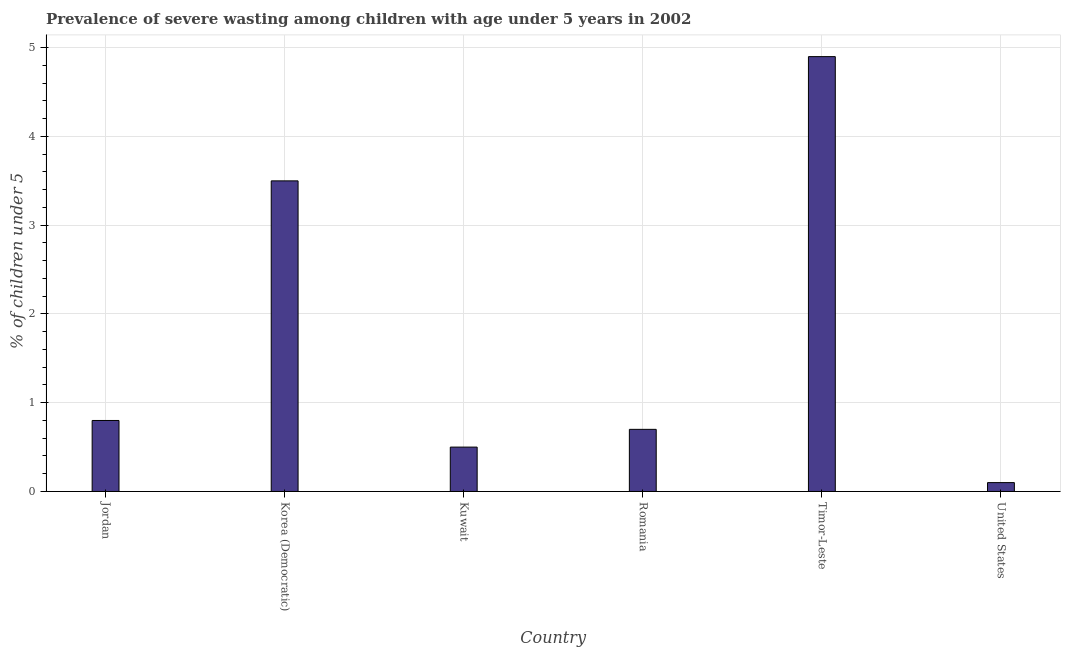What is the title of the graph?
Keep it short and to the point. Prevalence of severe wasting among children with age under 5 years in 2002. What is the label or title of the Y-axis?
Make the answer very short.  % of children under 5. What is the prevalence of severe wasting in United States?
Make the answer very short. 0.1. Across all countries, what is the maximum prevalence of severe wasting?
Offer a terse response. 4.9. Across all countries, what is the minimum prevalence of severe wasting?
Give a very brief answer. 0.1. In which country was the prevalence of severe wasting maximum?
Your response must be concise. Timor-Leste. In which country was the prevalence of severe wasting minimum?
Provide a succinct answer. United States. What is the sum of the prevalence of severe wasting?
Your response must be concise. 10.5. What is the difference between the prevalence of severe wasting in Romania and Timor-Leste?
Give a very brief answer. -4.2. What is the median prevalence of severe wasting?
Ensure brevity in your answer.  0.75. In how many countries, is the prevalence of severe wasting greater than 0.2 %?
Give a very brief answer. 5. What is the ratio of the prevalence of severe wasting in Jordan to that in Korea (Democratic)?
Ensure brevity in your answer.  0.23. Is the difference between the prevalence of severe wasting in Jordan and Korea (Democratic) greater than the difference between any two countries?
Keep it short and to the point. No. Is the sum of the prevalence of severe wasting in Korea (Democratic) and Romania greater than the maximum prevalence of severe wasting across all countries?
Give a very brief answer. No. In how many countries, is the prevalence of severe wasting greater than the average prevalence of severe wasting taken over all countries?
Offer a very short reply. 2. How many countries are there in the graph?
Offer a terse response. 6. What is the difference between two consecutive major ticks on the Y-axis?
Make the answer very short. 1. What is the  % of children under 5 in Jordan?
Offer a very short reply. 0.8. What is the  % of children under 5 of Korea (Democratic)?
Your response must be concise. 3.5. What is the  % of children under 5 in Romania?
Ensure brevity in your answer.  0.7. What is the  % of children under 5 of Timor-Leste?
Your answer should be compact. 4.9. What is the  % of children under 5 of United States?
Offer a very short reply. 0.1. What is the difference between the  % of children under 5 in Jordan and Romania?
Your answer should be compact. 0.1. What is the difference between the  % of children under 5 in Jordan and Timor-Leste?
Ensure brevity in your answer.  -4.1. What is the difference between the  % of children under 5 in Korea (Democratic) and Kuwait?
Your response must be concise. 3. What is the difference between the  % of children under 5 in Korea (Democratic) and Romania?
Your response must be concise. 2.8. What is the difference between the  % of children under 5 in Korea (Democratic) and United States?
Provide a short and direct response. 3.4. What is the difference between the  % of children under 5 in Kuwait and Timor-Leste?
Your answer should be compact. -4.4. What is the difference between the  % of children under 5 in Romania and Timor-Leste?
Offer a terse response. -4.2. What is the difference between the  % of children under 5 in Timor-Leste and United States?
Your response must be concise. 4.8. What is the ratio of the  % of children under 5 in Jordan to that in Korea (Democratic)?
Provide a succinct answer. 0.23. What is the ratio of the  % of children under 5 in Jordan to that in Romania?
Provide a short and direct response. 1.14. What is the ratio of the  % of children under 5 in Jordan to that in Timor-Leste?
Offer a terse response. 0.16. What is the ratio of the  % of children under 5 in Korea (Democratic) to that in Romania?
Provide a succinct answer. 5. What is the ratio of the  % of children under 5 in Korea (Democratic) to that in Timor-Leste?
Keep it short and to the point. 0.71. What is the ratio of the  % of children under 5 in Korea (Democratic) to that in United States?
Give a very brief answer. 35. What is the ratio of the  % of children under 5 in Kuwait to that in Romania?
Offer a very short reply. 0.71. What is the ratio of the  % of children under 5 in Kuwait to that in Timor-Leste?
Provide a succinct answer. 0.1. What is the ratio of the  % of children under 5 in Kuwait to that in United States?
Ensure brevity in your answer.  5. What is the ratio of the  % of children under 5 in Romania to that in Timor-Leste?
Ensure brevity in your answer.  0.14. What is the ratio of the  % of children under 5 in Romania to that in United States?
Ensure brevity in your answer.  7. 